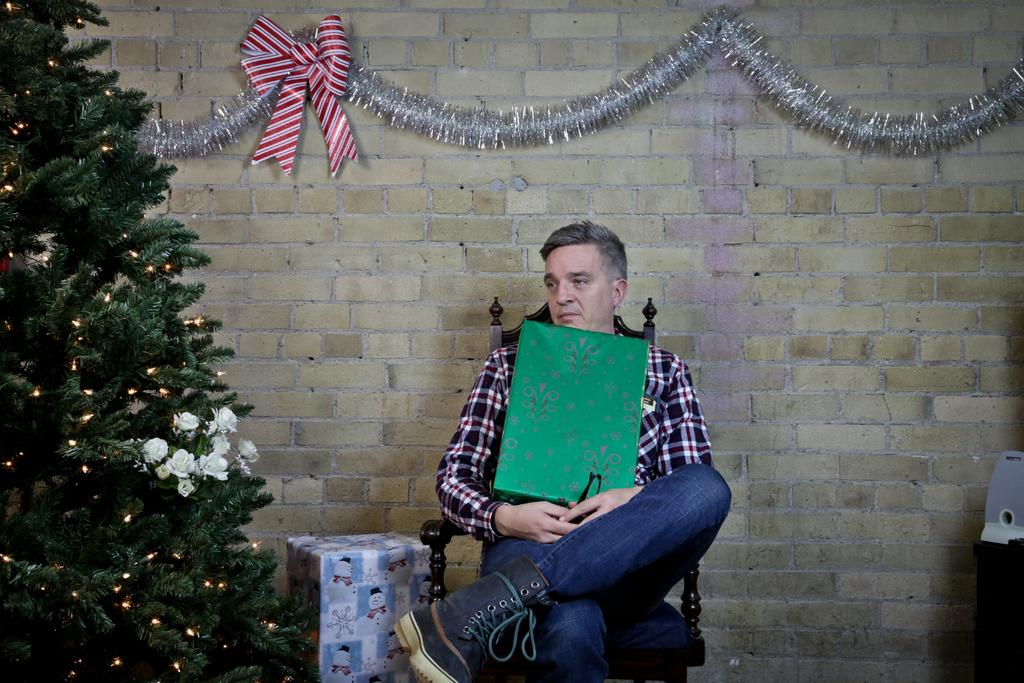What is the man in the image doing? The man is sitting on a chair in the image. What is the man holding in the image? The man is holding a box in the image. What can be seen on the left side of the image? There is a tree with flowers on the left side of the image. What is present on the wall in the background? There are decorative items on the wall in the background. Can you describe another object in the background? There is another box in the background. How many brothers and sisters does the man have in the image? There is no information about the man's siblings in the image, so we cannot determine the number of brothers and sisters he has. What type of comb is being used by the tree with flowers? There is no comb present in the image, as it features a man sitting on a chair, a box, a tree with flowers, decorative items on the wall, and another box in the background. 